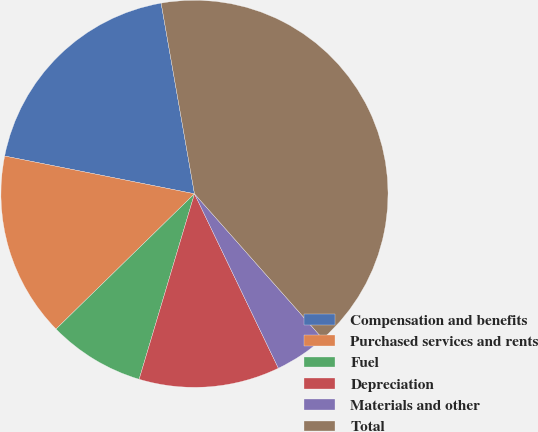<chart> <loc_0><loc_0><loc_500><loc_500><pie_chart><fcel>Compensation and benefits<fcel>Purchased services and rents<fcel>Fuel<fcel>Depreciation<fcel>Materials and other<fcel>Total<nl><fcel>19.12%<fcel>15.44%<fcel>8.07%<fcel>11.75%<fcel>4.39%<fcel>41.23%<nl></chart> 